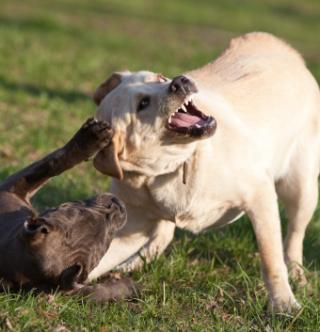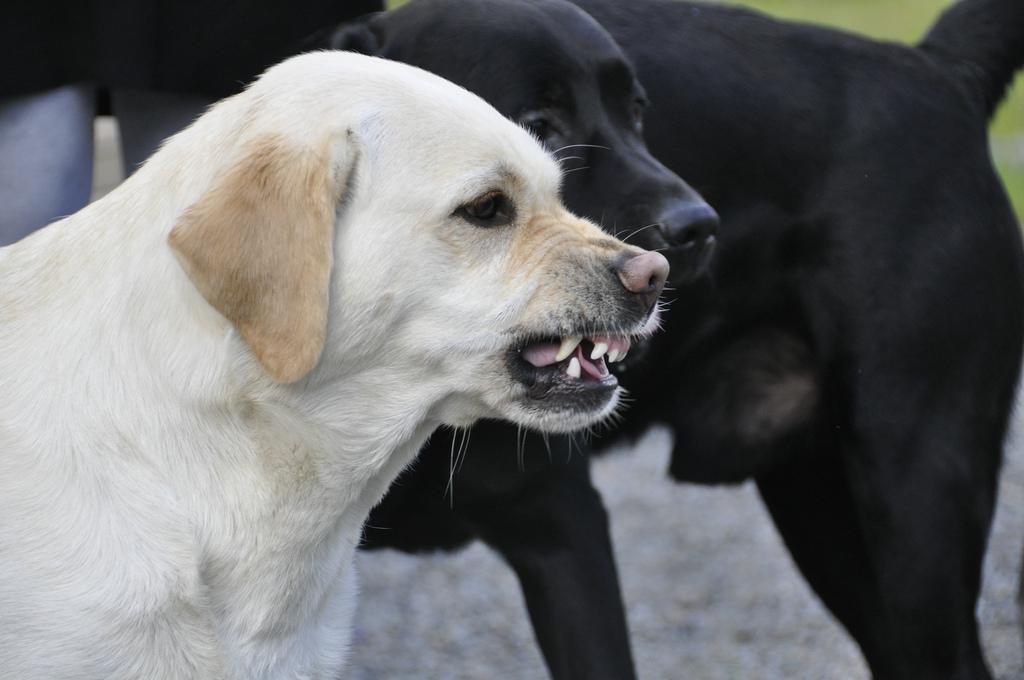The first image is the image on the left, the second image is the image on the right. Analyze the images presented: Is the assertion "An image shows an upright yellow lab baring its fangs, but not wearing any collar or muzzle." valid? Answer yes or no. Yes. The first image is the image on the left, the second image is the image on the right. For the images shown, is this caption "One of the images contains a puppy." true? Answer yes or no. No. 